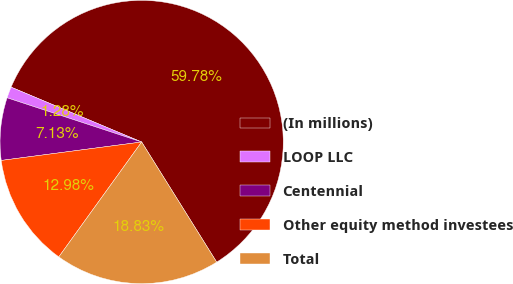Convert chart. <chart><loc_0><loc_0><loc_500><loc_500><pie_chart><fcel>(In millions)<fcel>LOOP LLC<fcel>Centennial<fcel>Other equity method investees<fcel>Total<nl><fcel>59.78%<fcel>1.28%<fcel>7.13%<fcel>12.98%<fcel>18.83%<nl></chart> 